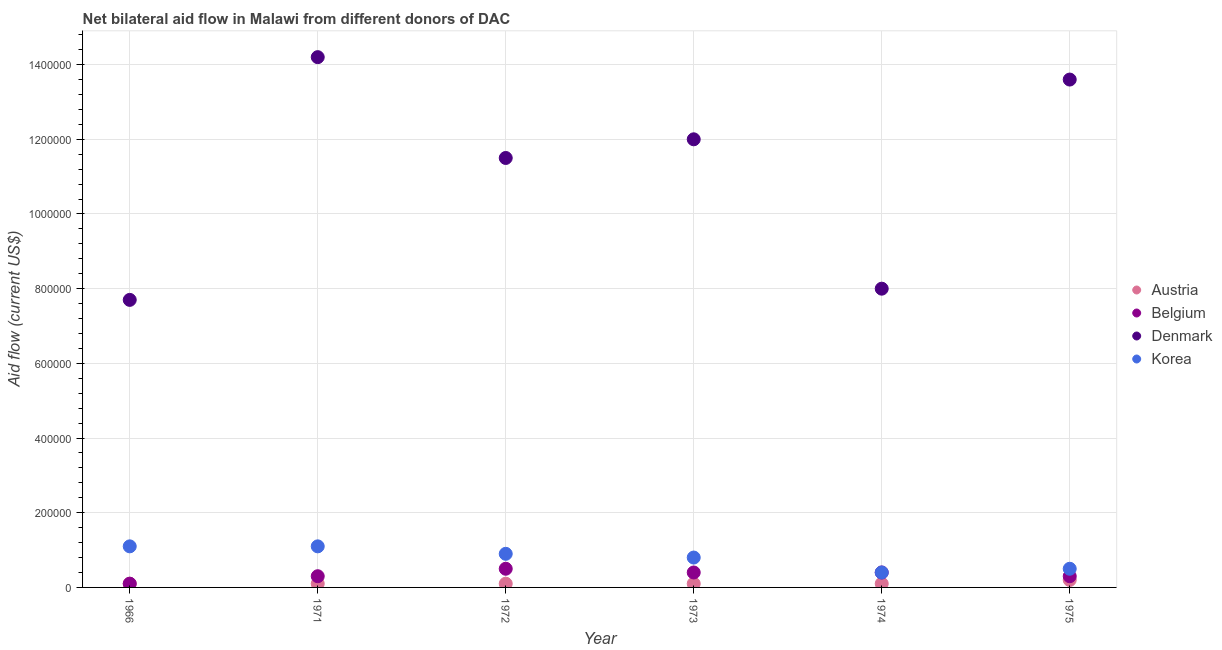How many different coloured dotlines are there?
Your response must be concise. 4. Is the number of dotlines equal to the number of legend labels?
Give a very brief answer. Yes. What is the amount of aid given by austria in 1972?
Offer a very short reply. 10000. Across all years, what is the maximum amount of aid given by belgium?
Your response must be concise. 5.00e+04. Across all years, what is the minimum amount of aid given by belgium?
Give a very brief answer. 10000. In which year was the amount of aid given by korea maximum?
Ensure brevity in your answer.  1966. In which year was the amount of aid given by austria minimum?
Ensure brevity in your answer.  1966. What is the total amount of aid given by korea in the graph?
Provide a short and direct response. 4.80e+05. What is the difference between the amount of aid given by austria in 1966 and that in 1973?
Make the answer very short. 0. What is the difference between the amount of aid given by denmark in 1972 and the amount of aid given by austria in 1974?
Provide a succinct answer. 1.14e+06. What is the average amount of aid given by belgium per year?
Ensure brevity in your answer.  3.33e+04. In the year 1973, what is the difference between the amount of aid given by belgium and amount of aid given by denmark?
Your response must be concise. -1.16e+06. What is the ratio of the amount of aid given by denmark in 1972 to that in 1974?
Your answer should be very brief. 1.44. What is the difference between the highest and the lowest amount of aid given by austria?
Your answer should be very brief. 10000. Is the sum of the amount of aid given by austria in 1972 and 1973 greater than the maximum amount of aid given by korea across all years?
Your answer should be compact. No. Is it the case that in every year, the sum of the amount of aid given by austria and amount of aid given by belgium is greater than the sum of amount of aid given by denmark and amount of aid given by korea?
Give a very brief answer. No. Is it the case that in every year, the sum of the amount of aid given by austria and amount of aid given by belgium is greater than the amount of aid given by denmark?
Make the answer very short. No. Does the amount of aid given by denmark monotonically increase over the years?
Offer a terse response. No. Is the amount of aid given by austria strictly less than the amount of aid given by korea over the years?
Provide a short and direct response. Yes. How many dotlines are there?
Your answer should be compact. 4. How many years are there in the graph?
Provide a short and direct response. 6. Are the values on the major ticks of Y-axis written in scientific E-notation?
Your answer should be very brief. No. Does the graph contain any zero values?
Make the answer very short. No. How many legend labels are there?
Provide a succinct answer. 4. How are the legend labels stacked?
Offer a very short reply. Vertical. What is the title of the graph?
Give a very brief answer. Net bilateral aid flow in Malawi from different donors of DAC. Does "Periodicity assessment" appear as one of the legend labels in the graph?
Your response must be concise. No. What is the label or title of the Y-axis?
Ensure brevity in your answer.  Aid flow (current US$). What is the Aid flow (current US$) of Belgium in 1966?
Your response must be concise. 10000. What is the Aid flow (current US$) in Denmark in 1966?
Your answer should be compact. 7.70e+05. What is the Aid flow (current US$) in Korea in 1966?
Ensure brevity in your answer.  1.10e+05. What is the Aid flow (current US$) in Austria in 1971?
Make the answer very short. 10000. What is the Aid flow (current US$) in Denmark in 1971?
Offer a very short reply. 1.42e+06. What is the Aid flow (current US$) in Korea in 1971?
Keep it short and to the point. 1.10e+05. What is the Aid flow (current US$) in Austria in 1972?
Make the answer very short. 10000. What is the Aid flow (current US$) of Belgium in 1972?
Ensure brevity in your answer.  5.00e+04. What is the Aid flow (current US$) in Denmark in 1972?
Make the answer very short. 1.15e+06. What is the Aid flow (current US$) of Korea in 1972?
Offer a very short reply. 9.00e+04. What is the Aid flow (current US$) in Belgium in 1973?
Your answer should be very brief. 4.00e+04. What is the Aid flow (current US$) in Denmark in 1973?
Your answer should be very brief. 1.20e+06. What is the Aid flow (current US$) in Austria in 1975?
Offer a very short reply. 2.00e+04. What is the Aid flow (current US$) in Belgium in 1975?
Provide a short and direct response. 3.00e+04. What is the Aid flow (current US$) in Denmark in 1975?
Make the answer very short. 1.36e+06. Across all years, what is the maximum Aid flow (current US$) in Belgium?
Provide a short and direct response. 5.00e+04. Across all years, what is the maximum Aid flow (current US$) in Denmark?
Provide a short and direct response. 1.42e+06. Across all years, what is the maximum Aid flow (current US$) of Korea?
Provide a succinct answer. 1.10e+05. Across all years, what is the minimum Aid flow (current US$) of Belgium?
Your answer should be very brief. 10000. Across all years, what is the minimum Aid flow (current US$) in Denmark?
Give a very brief answer. 7.70e+05. What is the total Aid flow (current US$) of Belgium in the graph?
Offer a terse response. 2.00e+05. What is the total Aid flow (current US$) of Denmark in the graph?
Keep it short and to the point. 6.70e+06. What is the difference between the Aid flow (current US$) in Belgium in 1966 and that in 1971?
Make the answer very short. -2.00e+04. What is the difference between the Aid flow (current US$) in Denmark in 1966 and that in 1971?
Your response must be concise. -6.50e+05. What is the difference between the Aid flow (current US$) of Belgium in 1966 and that in 1972?
Provide a short and direct response. -4.00e+04. What is the difference between the Aid flow (current US$) in Denmark in 1966 and that in 1972?
Your answer should be compact. -3.80e+05. What is the difference between the Aid flow (current US$) in Belgium in 1966 and that in 1973?
Keep it short and to the point. -3.00e+04. What is the difference between the Aid flow (current US$) of Denmark in 1966 and that in 1973?
Make the answer very short. -4.30e+05. What is the difference between the Aid flow (current US$) in Korea in 1966 and that in 1973?
Offer a very short reply. 3.00e+04. What is the difference between the Aid flow (current US$) of Belgium in 1966 and that in 1974?
Your answer should be compact. -3.00e+04. What is the difference between the Aid flow (current US$) in Belgium in 1966 and that in 1975?
Make the answer very short. -2.00e+04. What is the difference between the Aid flow (current US$) of Denmark in 1966 and that in 1975?
Offer a very short reply. -5.90e+05. What is the difference between the Aid flow (current US$) in Korea in 1966 and that in 1975?
Offer a terse response. 6.00e+04. What is the difference between the Aid flow (current US$) of Belgium in 1971 and that in 1973?
Your answer should be compact. -10000. What is the difference between the Aid flow (current US$) of Denmark in 1971 and that in 1973?
Your answer should be compact. 2.20e+05. What is the difference between the Aid flow (current US$) of Austria in 1971 and that in 1974?
Provide a succinct answer. 0. What is the difference between the Aid flow (current US$) in Denmark in 1971 and that in 1974?
Offer a very short reply. 6.20e+05. What is the difference between the Aid flow (current US$) of Korea in 1971 and that in 1974?
Provide a succinct answer. 7.00e+04. What is the difference between the Aid flow (current US$) of Belgium in 1971 and that in 1975?
Ensure brevity in your answer.  0. What is the difference between the Aid flow (current US$) of Korea in 1971 and that in 1975?
Your response must be concise. 6.00e+04. What is the difference between the Aid flow (current US$) in Belgium in 1972 and that in 1973?
Your answer should be compact. 10000. What is the difference between the Aid flow (current US$) in Denmark in 1972 and that in 1973?
Ensure brevity in your answer.  -5.00e+04. What is the difference between the Aid flow (current US$) of Denmark in 1972 and that in 1974?
Your answer should be very brief. 3.50e+05. What is the difference between the Aid flow (current US$) of Korea in 1972 and that in 1974?
Make the answer very short. 5.00e+04. What is the difference between the Aid flow (current US$) of Belgium in 1972 and that in 1975?
Provide a short and direct response. 2.00e+04. What is the difference between the Aid flow (current US$) in Denmark in 1972 and that in 1975?
Your response must be concise. -2.10e+05. What is the difference between the Aid flow (current US$) of Austria in 1973 and that in 1974?
Provide a short and direct response. 0. What is the difference between the Aid flow (current US$) of Austria in 1973 and that in 1975?
Your response must be concise. -10000. What is the difference between the Aid flow (current US$) in Denmark in 1973 and that in 1975?
Offer a very short reply. -1.60e+05. What is the difference between the Aid flow (current US$) of Austria in 1974 and that in 1975?
Keep it short and to the point. -10000. What is the difference between the Aid flow (current US$) of Denmark in 1974 and that in 1975?
Keep it short and to the point. -5.60e+05. What is the difference between the Aid flow (current US$) of Korea in 1974 and that in 1975?
Keep it short and to the point. -10000. What is the difference between the Aid flow (current US$) of Austria in 1966 and the Aid flow (current US$) of Belgium in 1971?
Offer a terse response. -2.00e+04. What is the difference between the Aid flow (current US$) of Austria in 1966 and the Aid flow (current US$) of Denmark in 1971?
Your answer should be very brief. -1.41e+06. What is the difference between the Aid flow (current US$) in Austria in 1966 and the Aid flow (current US$) in Korea in 1971?
Give a very brief answer. -1.00e+05. What is the difference between the Aid flow (current US$) of Belgium in 1966 and the Aid flow (current US$) of Denmark in 1971?
Ensure brevity in your answer.  -1.41e+06. What is the difference between the Aid flow (current US$) in Austria in 1966 and the Aid flow (current US$) in Denmark in 1972?
Give a very brief answer. -1.14e+06. What is the difference between the Aid flow (current US$) of Austria in 1966 and the Aid flow (current US$) of Korea in 1972?
Keep it short and to the point. -8.00e+04. What is the difference between the Aid flow (current US$) in Belgium in 1966 and the Aid flow (current US$) in Denmark in 1972?
Your answer should be compact. -1.14e+06. What is the difference between the Aid flow (current US$) in Belgium in 1966 and the Aid flow (current US$) in Korea in 1972?
Your answer should be compact. -8.00e+04. What is the difference between the Aid flow (current US$) in Denmark in 1966 and the Aid flow (current US$) in Korea in 1972?
Keep it short and to the point. 6.80e+05. What is the difference between the Aid flow (current US$) of Austria in 1966 and the Aid flow (current US$) of Denmark in 1973?
Provide a succinct answer. -1.19e+06. What is the difference between the Aid flow (current US$) in Austria in 1966 and the Aid flow (current US$) in Korea in 1973?
Give a very brief answer. -7.00e+04. What is the difference between the Aid flow (current US$) in Belgium in 1966 and the Aid flow (current US$) in Denmark in 1973?
Give a very brief answer. -1.19e+06. What is the difference between the Aid flow (current US$) of Belgium in 1966 and the Aid flow (current US$) of Korea in 1973?
Provide a short and direct response. -7.00e+04. What is the difference between the Aid flow (current US$) of Denmark in 1966 and the Aid flow (current US$) of Korea in 1973?
Offer a very short reply. 6.90e+05. What is the difference between the Aid flow (current US$) of Austria in 1966 and the Aid flow (current US$) of Belgium in 1974?
Provide a short and direct response. -3.00e+04. What is the difference between the Aid flow (current US$) of Austria in 1966 and the Aid flow (current US$) of Denmark in 1974?
Your response must be concise. -7.90e+05. What is the difference between the Aid flow (current US$) in Austria in 1966 and the Aid flow (current US$) in Korea in 1974?
Give a very brief answer. -3.00e+04. What is the difference between the Aid flow (current US$) of Belgium in 1966 and the Aid flow (current US$) of Denmark in 1974?
Keep it short and to the point. -7.90e+05. What is the difference between the Aid flow (current US$) of Denmark in 1966 and the Aid flow (current US$) of Korea in 1974?
Ensure brevity in your answer.  7.30e+05. What is the difference between the Aid flow (current US$) of Austria in 1966 and the Aid flow (current US$) of Belgium in 1975?
Your response must be concise. -2.00e+04. What is the difference between the Aid flow (current US$) of Austria in 1966 and the Aid flow (current US$) of Denmark in 1975?
Your answer should be compact. -1.35e+06. What is the difference between the Aid flow (current US$) of Austria in 1966 and the Aid flow (current US$) of Korea in 1975?
Ensure brevity in your answer.  -4.00e+04. What is the difference between the Aid flow (current US$) of Belgium in 1966 and the Aid flow (current US$) of Denmark in 1975?
Provide a short and direct response. -1.35e+06. What is the difference between the Aid flow (current US$) in Denmark in 1966 and the Aid flow (current US$) in Korea in 1975?
Offer a very short reply. 7.20e+05. What is the difference between the Aid flow (current US$) in Austria in 1971 and the Aid flow (current US$) in Denmark in 1972?
Offer a terse response. -1.14e+06. What is the difference between the Aid flow (current US$) of Austria in 1971 and the Aid flow (current US$) of Korea in 1972?
Your answer should be compact. -8.00e+04. What is the difference between the Aid flow (current US$) of Belgium in 1971 and the Aid flow (current US$) of Denmark in 1972?
Give a very brief answer. -1.12e+06. What is the difference between the Aid flow (current US$) in Belgium in 1971 and the Aid flow (current US$) in Korea in 1972?
Provide a succinct answer. -6.00e+04. What is the difference between the Aid flow (current US$) of Denmark in 1971 and the Aid flow (current US$) of Korea in 1972?
Make the answer very short. 1.33e+06. What is the difference between the Aid flow (current US$) of Austria in 1971 and the Aid flow (current US$) of Belgium in 1973?
Give a very brief answer. -3.00e+04. What is the difference between the Aid flow (current US$) in Austria in 1971 and the Aid flow (current US$) in Denmark in 1973?
Give a very brief answer. -1.19e+06. What is the difference between the Aid flow (current US$) in Austria in 1971 and the Aid flow (current US$) in Korea in 1973?
Your answer should be compact. -7.00e+04. What is the difference between the Aid flow (current US$) in Belgium in 1971 and the Aid flow (current US$) in Denmark in 1973?
Provide a short and direct response. -1.17e+06. What is the difference between the Aid flow (current US$) in Belgium in 1971 and the Aid flow (current US$) in Korea in 1973?
Your response must be concise. -5.00e+04. What is the difference between the Aid flow (current US$) in Denmark in 1971 and the Aid flow (current US$) in Korea in 1973?
Your response must be concise. 1.34e+06. What is the difference between the Aid flow (current US$) of Austria in 1971 and the Aid flow (current US$) of Belgium in 1974?
Your response must be concise. -3.00e+04. What is the difference between the Aid flow (current US$) of Austria in 1971 and the Aid flow (current US$) of Denmark in 1974?
Provide a short and direct response. -7.90e+05. What is the difference between the Aid flow (current US$) in Belgium in 1971 and the Aid flow (current US$) in Denmark in 1974?
Your response must be concise. -7.70e+05. What is the difference between the Aid flow (current US$) in Denmark in 1971 and the Aid flow (current US$) in Korea in 1974?
Your answer should be very brief. 1.38e+06. What is the difference between the Aid flow (current US$) of Austria in 1971 and the Aid flow (current US$) of Belgium in 1975?
Offer a terse response. -2.00e+04. What is the difference between the Aid flow (current US$) of Austria in 1971 and the Aid flow (current US$) of Denmark in 1975?
Provide a short and direct response. -1.35e+06. What is the difference between the Aid flow (current US$) of Austria in 1971 and the Aid flow (current US$) of Korea in 1975?
Offer a very short reply. -4.00e+04. What is the difference between the Aid flow (current US$) in Belgium in 1971 and the Aid flow (current US$) in Denmark in 1975?
Your response must be concise. -1.33e+06. What is the difference between the Aid flow (current US$) in Belgium in 1971 and the Aid flow (current US$) in Korea in 1975?
Offer a very short reply. -2.00e+04. What is the difference between the Aid flow (current US$) of Denmark in 1971 and the Aid flow (current US$) of Korea in 1975?
Your answer should be compact. 1.37e+06. What is the difference between the Aid flow (current US$) of Austria in 1972 and the Aid flow (current US$) of Denmark in 1973?
Keep it short and to the point. -1.19e+06. What is the difference between the Aid flow (current US$) in Belgium in 1972 and the Aid flow (current US$) in Denmark in 1973?
Give a very brief answer. -1.15e+06. What is the difference between the Aid flow (current US$) in Denmark in 1972 and the Aid flow (current US$) in Korea in 1973?
Provide a succinct answer. 1.07e+06. What is the difference between the Aid flow (current US$) of Austria in 1972 and the Aid flow (current US$) of Belgium in 1974?
Ensure brevity in your answer.  -3.00e+04. What is the difference between the Aid flow (current US$) of Austria in 1972 and the Aid flow (current US$) of Denmark in 1974?
Offer a very short reply. -7.90e+05. What is the difference between the Aid flow (current US$) in Austria in 1972 and the Aid flow (current US$) in Korea in 1974?
Keep it short and to the point. -3.00e+04. What is the difference between the Aid flow (current US$) in Belgium in 1972 and the Aid flow (current US$) in Denmark in 1974?
Your response must be concise. -7.50e+05. What is the difference between the Aid flow (current US$) in Belgium in 1972 and the Aid flow (current US$) in Korea in 1974?
Ensure brevity in your answer.  10000. What is the difference between the Aid flow (current US$) in Denmark in 1972 and the Aid flow (current US$) in Korea in 1974?
Offer a very short reply. 1.11e+06. What is the difference between the Aid flow (current US$) in Austria in 1972 and the Aid flow (current US$) in Belgium in 1975?
Give a very brief answer. -2.00e+04. What is the difference between the Aid flow (current US$) in Austria in 1972 and the Aid flow (current US$) in Denmark in 1975?
Provide a short and direct response. -1.35e+06. What is the difference between the Aid flow (current US$) of Belgium in 1972 and the Aid flow (current US$) of Denmark in 1975?
Your response must be concise. -1.31e+06. What is the difference between the Aid flow (current US$) in Belgium in 1972 and the Aid flow (current US$) in Korea in 1975?
Offer a terse response. 0. What is the difference between the Aid flow (current US$) in Denmark in 1972 and the Aid flow (current US$) in Korea in 1975?
Keep it short and to the point. 1.10e+06. What is the difference between the Aid flow (current US$) of Austria in 1973 and the Aid flow (current US$) of Belgium in 1974?
Offer a terse response. -3.00e+04. What is the difference between the Aid flow (current US$) of Austria in 1973 and the Aid flow (current US$) of Denmark in 1974?
Provide a succinct answer. -7.90e+05. What is the difference between the Aid flow (current US$) in Belgium in 1973 and the Aid flow (current US$) in Denmark in 1974?
Give a very brief answer. -7.60e+05. What is the difference between the Aid flow (current US$) in Belgium in 1973 and the Aid flow (current US$) in Korea in 1974?
Your answer should be very brief. 0. What is the difference between the Aid flow (current US$) in Denmark in 1973 and the Aid flow (current US$) in Korea in 1974?
Your response must be concise. 1.16e+06. What is the difference between the Aid flow (current US$) in Austria in 1973 and the Aid flow (current US$) in Denmark in 1975?
Make the answer very short. -1.35e+06. What is the difference between the Aid flow (current US$) of Belgium in 1973 and the Aid flow (current US$) of Denmark in 1975?
Provide a succinct answer. -1.32e+06. What is the difference between the Aid flow (current US$) of Belgium in 1973 and the Aid flow (current US$) of Korea in 1975?
Ensure brevity in your answer.  -10000. What is the difference between the Aid flow (current US$) of Denmark in 1973 and the Aid flow (current US$) of Korea in 1975?
Provide a short and direct response. 1.15e+06. What is the difference between the Aid flow (current US$) in Austria in 1974 and the Aid flow (current US$) in Belgium in 1975?
Keep it short and to the point. -2.00e+04. What is the difference between the Aid flow (current US$) in Austria in 1974 and the Aid flow (current US$) in Denmark in 1975?
Offer a terse response. -1.35e+06. What is the difference between the Aid flow (current US$) of Austria in 1974 and the Aid flow (current US$) of Korea in 1975?
Provide a short and direct response. -4.00e+04. What is the difference between the Aid flow (current US$) of Belgium in 1974 and the Aid flow (current US$) of Denmark in 1975?
Your answer should be compact. -1.32e+06. What is the difference between the Aid flow (current US$) in Belgium in 1974 and the Aid flow (current US$) in Korea in 1975?
Make the answer very short. -10000. What is the difference between the Aid flow (current US$) in Denmark in 1974 and the Aid flow (current US$) in Korea in 1975?
Provide a short and direct response. 7.50e+05. What is the average Aid flow (current US$) of Austria per year?
Ensure brevity in your answer.  1.17e+04. What is the average Aid flow (current US$) in Belgium per year?
Provide a succinct answer. 3.33e+04. What is the average Aid flow (current US$) of Denmark per year?
Give a very brief answer. 1.12e+06. What is the average Aid flow (current US$) of Korea per year?
Keep it short and to the point. 8.00e+04. In the year 1966, what is the difference between the Aid flow (current US$) in Austria and Aid flow (current US$) in Denmark?
Offer a very short reply. -7.60e+05. In the year 1966, what is the difference between the Aid flow (current US$) of Belgium and Aid flow (current US$) of Denmark?
Give a very brief answer. -7.60e+05. In the year 1966, what is the difference between the Aid flow (current US$) in Denmark and Aid flow (current US$) in Korea?
Provide a succinct answer. 6.60e+05. In the year 1971, what is the difference between the Aid flow (current US$) in Austria and Aid flow (current US$) in Denmark?
Your answer should be compact. -1.41e+06. In the year 1971, what is the difference between the Aid flow (current US$) of Austria and Aid flow (current US$) of Korea?
Your response must be concise. -1.00e+05. In the year 1971, what is the difference between the Aid flow (current US$) of Belgium and Aid flow (current US$) of Denmark?
Ensure brevity in your answer.  -1.39e+06. In the year 1971, what is the difference between the Aid flow (current US$) of Denmark and Aid flow (current US$) of Korea?
Provide a short and direct response. 1.31e+06. In the year 1972, what is the difference between the Aid flow (current US$) of Austria and Aid flow (current US$) of Denmark?
Your response must be concise. -1.14e+06. In the year 1972, what is the difference between the Aid flow (current US$) of Austria and Aid flow (current US$) of Korea?
Give a very brief answer. -8.00e+04. In the year 1972, what is the difference between the Aid flow (current US$) of Belgium and Aid flow (current US$) of Denmark?
Offer a terse response. -1.10e+06. In the year 1972, what is the difference between the Aid flow (current US$) in Denmark and Aid flow (current US$) in Korea?
Provide a succinct answer. 1.06e+06. In the year 1973, what is the difference between the Aid flow (current US$) in Austria and Aid flow (current US$) in Belgium?
Ensure brevity in your answer.  -3.00e+04. In the year 1973, what is the difference between the Aid flow (current US$) of Austria and Aid flow (current US$) of Denmark?
Your answer should be very brief. -1.19e+06. In the year 1973, what is the difference between the Aid flow (current US$) of Belgium and Aid flow (current US$) of Denmark?
Your response must be concise. -1.16e+06. In the year 1973, what is the difference between the Aid flow (current US$) of Denmark and Aid flow (current US$) of Korea?
Provide a succinct answer. 1.12e+06. In the year 1974, what is the difference between the Aid flow (current US$) in Austria and Aid flow (current US$) in Belgium?
Provide a succinct answer. -3.00e+04. In the year 1974, what is the difference between the Aid flow (current US$) of Austria and Aid flow (current US$) of Denmark?
Your answer should be compact. -7.90e+05. In the year 1974, what is the difference between the Aid flow (current US$) of Austria and Aid flow (current US$) of Korea?
Your answer should be very brief. -3.00e+04. In the year 1974, what is the difference between the Aid flow (current US$) in Belgium and Aid flow (current US$) in Denmark?
Make the answer very short. -7.60e+05. In the year 1974, what is the difference between the Aid flow (current US$) of Denmark and Aid flow (current US$) of Korea?
Keep it short and to the point. 7.60e+05. In the year 1975, what is the difference between the Aid flow (current US$) in Austria and Aid flow (current US$) in Denmark?
Provide a succinct answer. -1.34e+06. In the year 1975, what is the difference between the Aid flow (current US$) of Austria and Aid flow (current US$) of Korea?
Provide a succinct answer. -3.00e+04. In the year 1975, what is the difference between the Aid flow (current US$) of Belgium and Aid flow (current US$) of Denmark?
Your answer should be compact. -1.33e+06. In the year 1975, what is the difference between the Aid flow (current US$) of Denmark and Aid flow (current US$) of Korea?
Your answer should be compact. 1.31e+06. What is the ratio of the Aid flow (current US$) in Denmark in 1966 to that in 1971?
Provide a short and direct response. 0.54. What is the ratio of the Aid flow (current US$) of Korea in 1966 to that in 1971?
Ensure brevity in your answer.  1. What is the ratio of the Aid flow (current US$) in Belgium in 1966 to that in 1972?
Your answer should be very brief. 0.2. What is the ratio of the Aid flow (current US$) of Denmark in 1966 to that in 1972?
Provide a short and direct response. 0.67. What is the ratio of the Aid flow (current US$) in Korea in 1966 to that in 1972?
Your answer should be very brief. 1.22. What is the ratio of the Aid flow (current US$) in Austria in 1966 to that in 1973?
Keep it short and to the point. 1. What is the ratio of the Aid flow (current US$) in Belgium in 1966 to that in 1973?
Your response must be concise. 0.25. What is the ratio of the Aid flow (current US$) in Denmark in 1966 to that in 1973?
Give a very brief answer. 0.64. What is the ratio of the Aid flow (current US$) in Korea in 1966 to that in 1973?
Ensure brevity in your answer.  1.38. What is the ratio of the Aid flow (current US$) of Austria in 1966 to that in 1974?
Make the answer very short. 1. What is the ratio of the Aid flow (current US$) in Belgium in 1966 to that in 1974?
Your answer should be very brief. 0.25. What is the ratio of the Aid flow (current US$) of Denmark in 1966 to that in 1974?
Your answer should be compact. 0.96. What is the ratio of the Aid flow (current US$) in Korea in 1966 to that in 1974?
Ensure brevity in your answer.  2.75. What is the ratio of the Aid flow (current US$) of Austria in 1966 to that in 1975?
Make the answer very short. 0.5. What is the ratio of the Aid flow (current US$) of Denmark in 1966 to that in 1975?
Provide a succinct answer. 0.57. What is the ratio of the Aid flow (current US$) in Austria in 1971 to that in 1972?
Your answer should be compact. 1. What is the ratio of the Aid flow (current US$) of Denmark in 1971 to that in 1972?
Keep it short and to the point. 1.23. What is the ratio of the Aid flow (current US$) of Korea in 1971 to that in 1972?
Your response must be concise. 1.22. What is the ratio of the Aid flow (current US$) of Belgium in 1971 to that in 1973?
Provide a short and direct response. 0.75. What is the ratio of the Aid flow (current US$) in Denmark in 1971 to that in 1973?
Your answer should be very brief. 1.18. What is the ratio of the Aid flow (current US$) of Korea in 1971 to that in 1973?
Offer a terse response. 1.38. What is the ratio of the Aid flow (current US$) of Denmark in 1971 to that in 1974?
Your answer should be compact. 1.77. What is the ratio of the Aid flow (current US$) of Korea in 1971 to that in 1974?
Ensure brevity in your answer.  2.75. What is the ratio of the Aid flow (current US$) of Denmark in 1971 to that in 1975?
Provide a succinct answer. 1.04. What is the ratio of the Aid flow (current US$) in Austria in 1972 to that in 1973?
Your answer should be very brief. 1. What is the ratio of the Aid flow (current US$) of Belgium in 1972 to that in 1973?
Ensure brevity in your answer.  1.25. What is the ratio of the Aid flow (current US$) in Austria in 1972 to that in 1974?
Ensure brevity in your answer.  1. What is the ratio of the Aid flow (current US$) in Denmark in 1972 to that in 1974?
Your response must be concise. 1.44. What is the ratio of the Aid flow (current US$) of Korea in 1972 to that in 1974?
Your response must be concise. 2.25. What is the ratio of the Aid flow (current US$) of Austria in 1972 to that in 1975?
Provide a succinct answer. 0.5. What is the ratio of the Aid flow (current US$) in Denmark in 1972 to that in 1975?
Your response must be concise. 0.85. What is the ratio of the Aid flow (current US$) in Austria in 1973 to that in 1974?
Offer a very short reply. 1. What is the ratio of the Aid flow (current US$) in Belgium in 1973 to that in 1974?
Provide a succinct answer. 1. What is the ratio of the Aid flow (current US$) in Denmark in 1973 to that in 1974?
Make the answer very short. 1.5. What is the ratio of the Aid flow (current US$) of Korea in 1973 to that in 1974?
Keep it short and to the point. 2. What is the ratio of the Aid flow (current US$) of Austria in 1973 to that in 1975?
Ensure brevity in your answer.  0.5. What is the ratio of the Aid flow (current US$) of Denmark in 1973 to that in 1975?
Ensure brevity in your answer.  0.88. What is the ratio of the Aid flow (current US$) in Korea in 1973 to that in 1975?
Your answer should be very brief. 1.6. What is the ratio of the Aid flow (current US$) of Austria in 1974 to that in 1975?
Keep it short and to the point. 0.5. What is the ratio of the Aid flow (current US$) in Denmark in 1974 to that in 1975?
Provide a succinct answer. 0.59. What is the ratio of the Aid flow (current US$) in Korea in 1974 to that in 1975?
Keep it short and to the point. 0.8. What is the difference between the highest and the second highest Aid flow (current US$) of Belgium?
Offer a terse response. 10000. What is the difference between the highest and the second highest Aid flow (current US$) of Korea?
Keep it short and to the point. 0. What is the difference between the highest and the lowest Aid flow (current US$) in Denmark?
Ensure brevity in your answer.  6.50e+05. 